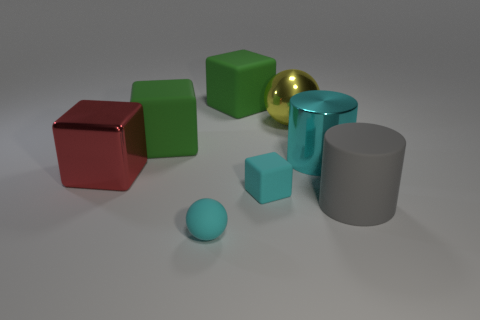Is the big yellow ball made of the same material as the gray object?
Your answer should be very brief. No. There is a red object that is the same material as the cyan cylinder; what shape is it?
Your response must be concise. Cube. Is the number of metal cylinders less than the number of small red objects?
Ensure brevity in your answer.  No. There is a object that is in front of the big red thing and behind the large gray object; what is its material?
Your answer should be compact. Rubber. What is the size of the green rubber thing that is left of the green thing that is on the right side of the cyan rubber thing that is in front of the small cyan rubber block?
Provide a short and direct response. Large. There is a gray object; does it have the same shape as the tiny object in front of the big gray cylinder?
Your answer should be compact. No. What number of big objects are both on the left side of the big cyan cylinder and to the right of the red object?
Your answer should be very brief. 3. How many red objects are shiny cubes or large rubber things?
Give a very brief answer. 1. Does the sphere that is in front of the cyan block have the same color as the cylinder that is behind the big gray rubber thing?
Keep it short and to the point. Yes. There is a ball that is right of the small object that is behind the large cylinder in front of the metal cylinder; what color is it?
Give a very brief answer. Yellow. 